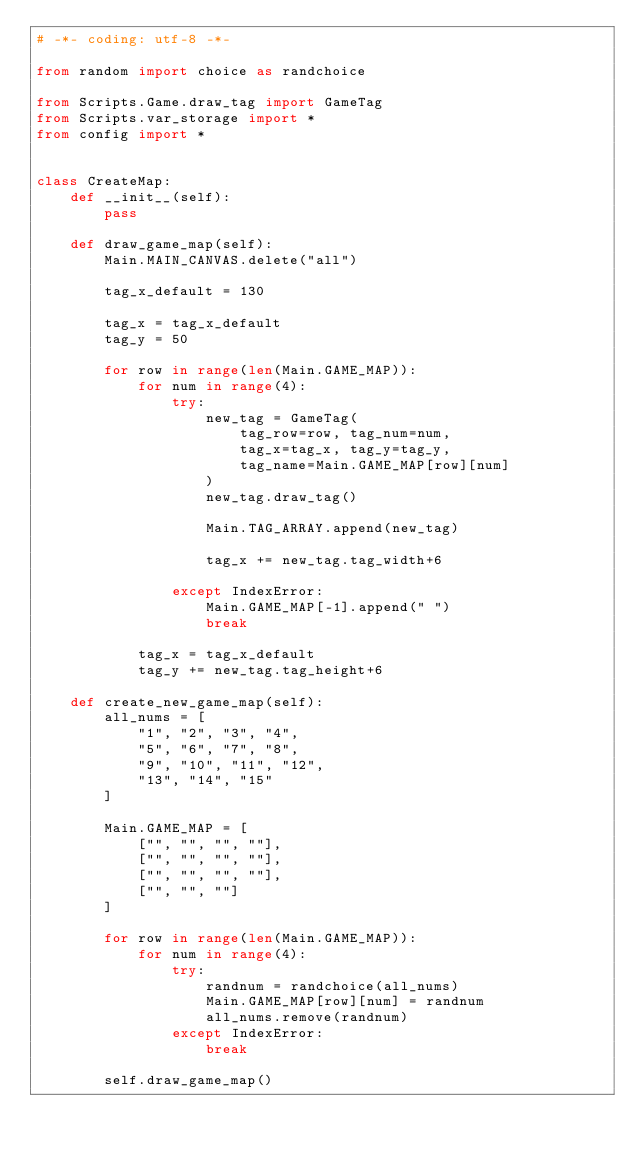Convert code to text. <code><loc_0><loc_0><loc_500><loc_500><_Python_># -*- coding: utf-8 -*-

from random import choice as randchoice

from Scripts.Game.draw_tag import GameTag
from Scripts.var_storage import *
from config import *


class CreateMap:
    def __init__(self):
        pass

    def draw_game_map(self):
        Main.MAIN_CANVAS.delete("all")

        tag_x_default = 130

        tag_x = tag_x_default
        tag_y = 50

        for row in range(len(Main.GAME_MAP)):
            for num in range(4):
                try:
                    new_tag = GameTag(
                        tag_row=row, tag_num=num,
                        tag_x=tag_x, tag_y=tag_y,
                        tag_name=Main.GAME_MAP[row][num]
                    )
                    new_tag.draw_tag()

                    Main.TAG_ARRAY.append(new_tag)

                    tag_x += new_tag.tag_width+6

                except IndexError:
                    Main.GAME_MAP[-1].append(" ")
                    break

            tag_x = tag_x_default
            tag_y += new_tag.tag_height+6

    def create_new_game_map(self):
        all_nums = [
            "1", "2", "3", "4",
            "5", "6", "7", "8",
            "9", "10", "11", "12",
            "13", "14", "15"
        ]

        Main.GAME_MAP = [
            ["", "", "", ""],
            ["", "", "", ""],
            ["", "", "", ""],
            ["", "", ""]
        ]

        for row in range(len(Main.GAME_MAP)):
            for num in range(4):
                try:
                    randnum = randchoice(all_nums)
                    Main.GAME_MAP[row][num] = randnum
                    all_nums.remove(randnum)
                except IndexError:
                    break

        self.draw_game_map()
</code> 